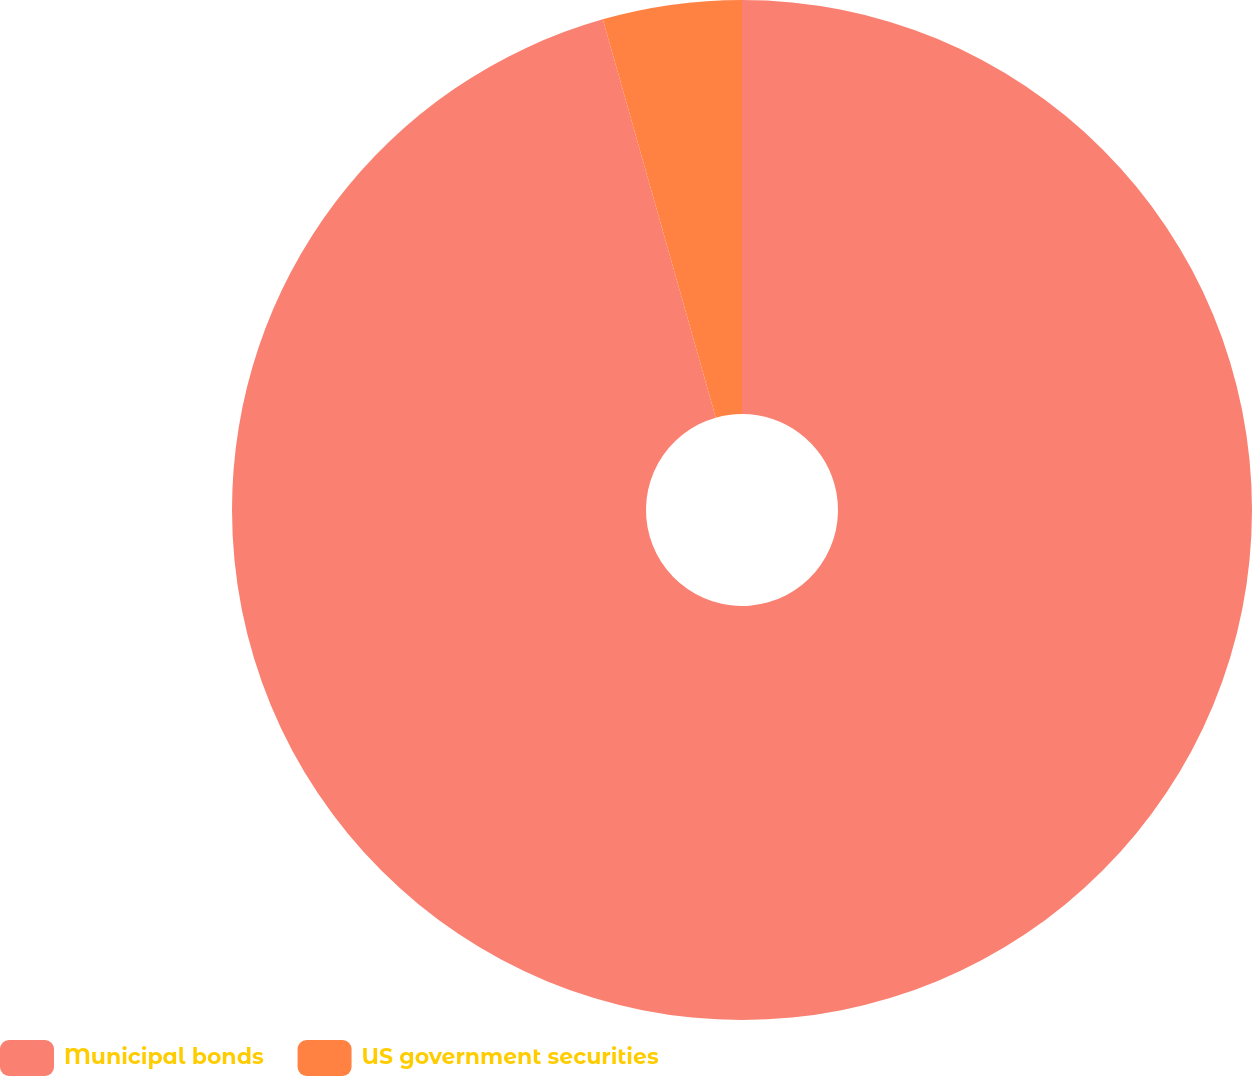Convert chart to OTSL. <chart><loc_0><loc_0><loc_500><loc_500><pie_chart><fcel>Municipal bonds<fcel>US government securities<nl><fcel>95.6%<fcel>4.4%<nl></chart> 